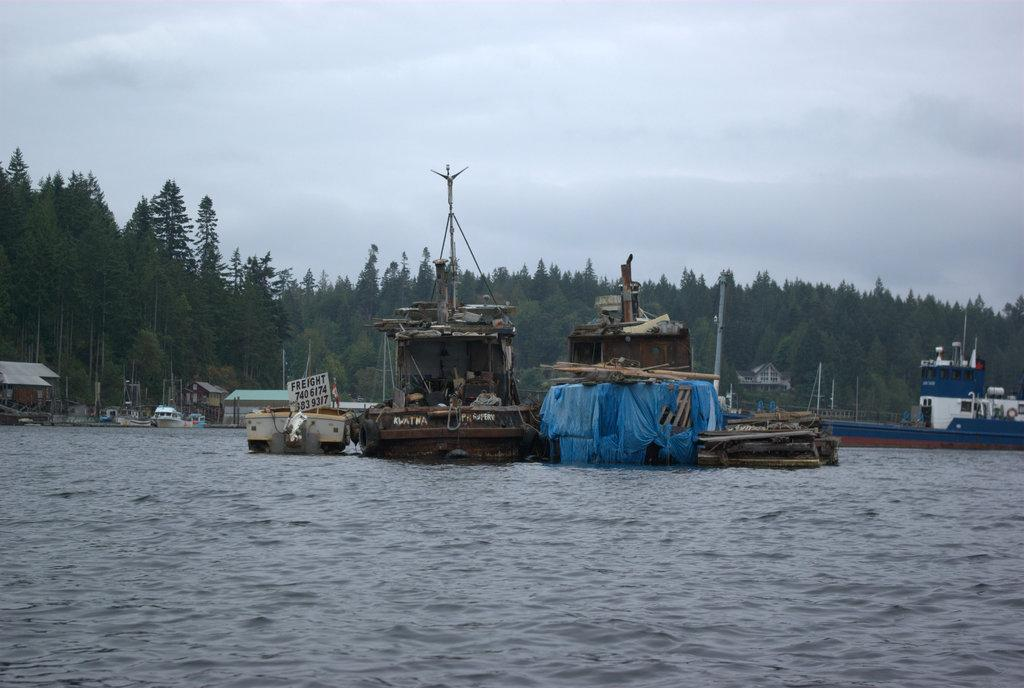What is the main element present in the image? There is water in the image. What types of watercraft can be seen in the image? There are ships and boats in the image. What can be seen in the background of the image? There are trees and a cloudy sky in the background of the image. How does the pain in the image walk towards the back? There is no pain or walking person present in the image; it features water, ships, boats, trees, and a cloudy sky. 